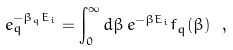<formula> <loc_0><loc_0><loc_500><loc_500>e ^ { - \beta _ { q } E _ { i } } _ { q } = \int ^ { \infty } _ { 0 } d \beta \, e ^ { - \beta E _ { i } } f _ { q } ( \beta ) \ ,</formula> 